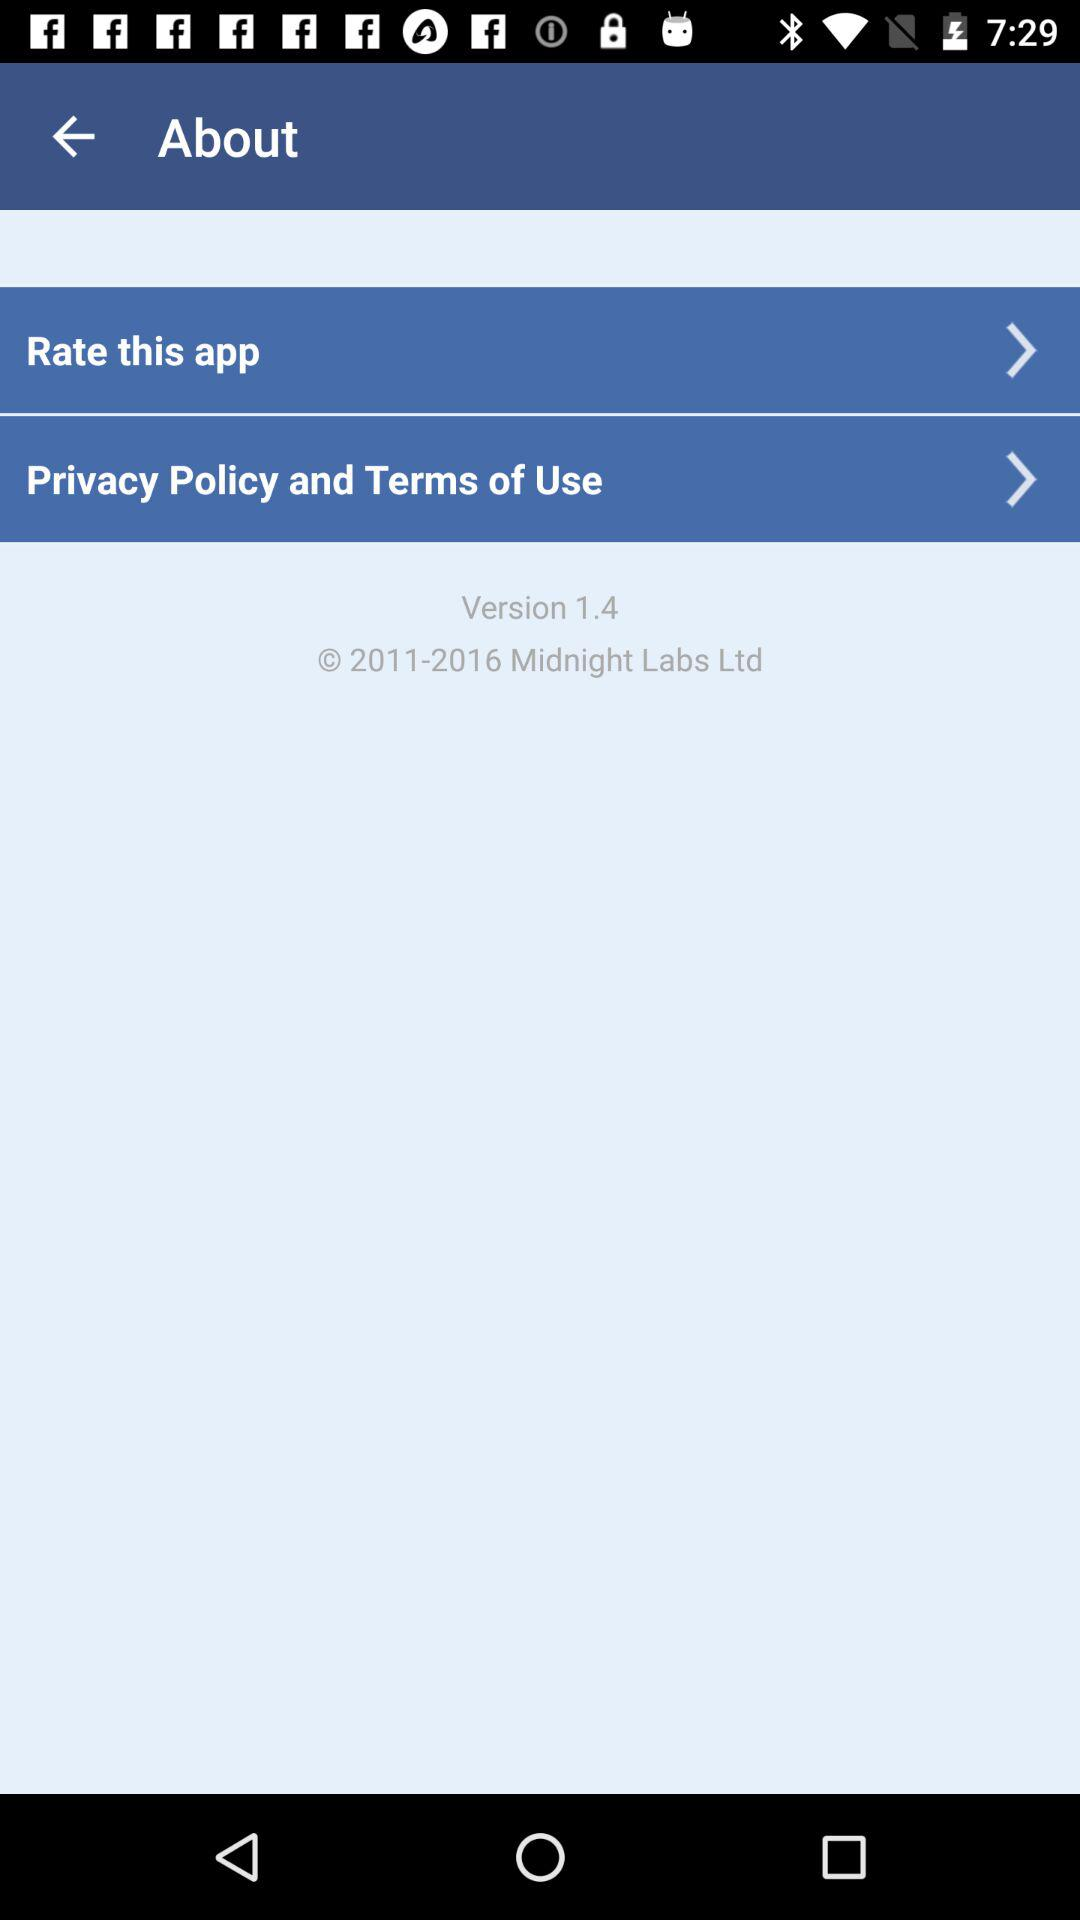What is the version? The version is 1.4. 